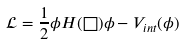<formula> <loc_0><loc_0><loc_500><loc_500>\mathcal { L } = \frac { 1 } { 2 } \phi H ( \Box ) \phi - V _ { i n t } ( \phi )</formula> 